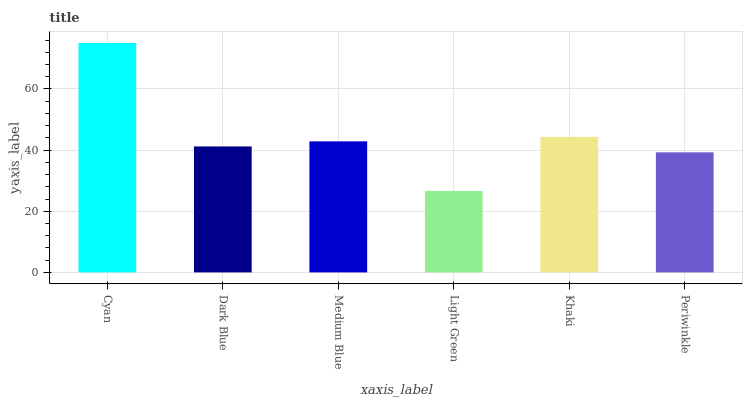Is Dark Blue the minimum?
Answer yes or no. No. Is Dark Blue the maximum?
Answer yes or no. No. Is Cyan greater than Dark Blue?
Answer yes or no. Yes. Is Dark Blue less than Cyan?
Answer yes or no. Yes. Is Dark Blue greater than Cyan?
Answer yes or no. No. Is Cyan less than Dark Blue?
Answer yes or no. No. Is Medium Blue the high median?
Answer yes or no. Yes. Is Dark Blue the low median?
Answer yes or no. Yes. Is Khaki the high median?
Answer yes or no. No. Is Light Green the low median?
Answer yes or no. No. 